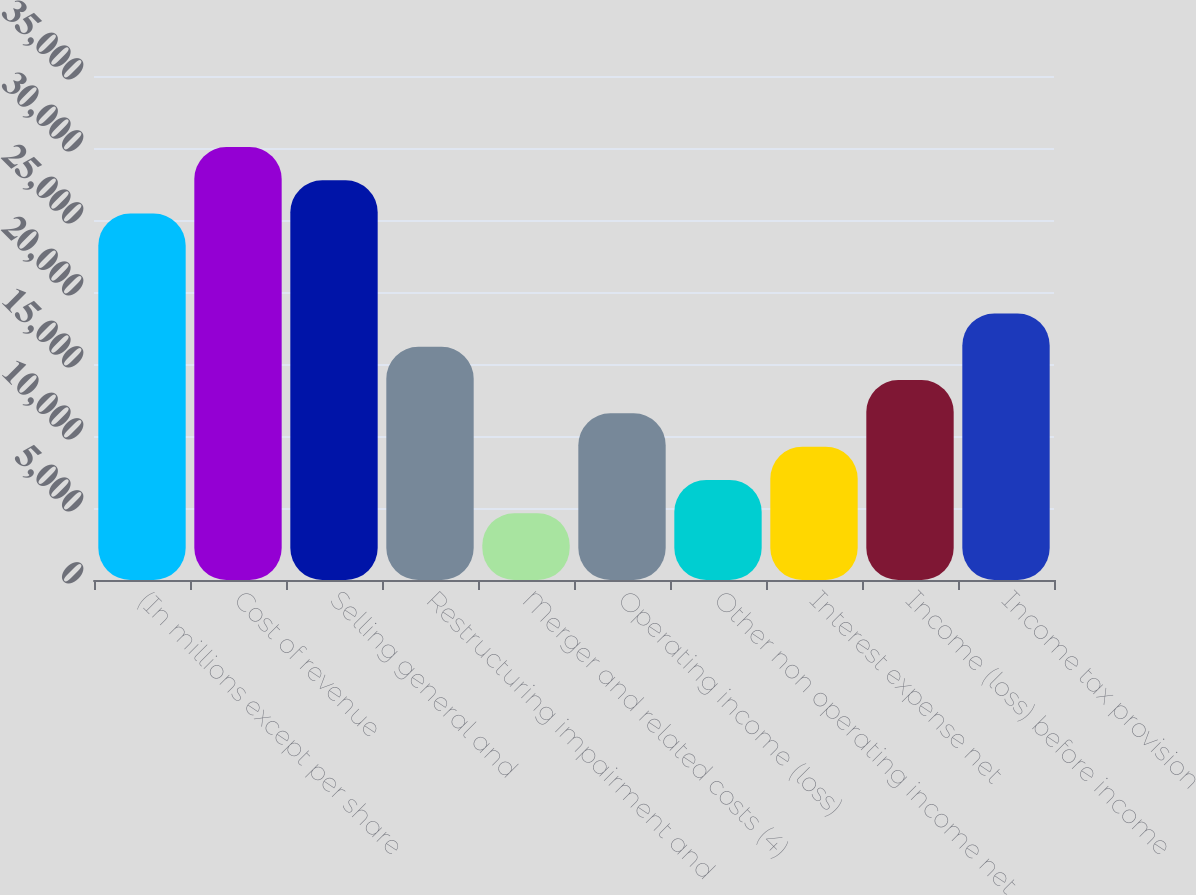Convert chart. <chart><loc_0><loc_0><loc_500><loc_500><bar_chart><fcel>(In millions except per share<fcel>Cost of revenue<fcel>Selling general and<fcel>Restructuring impairment and<fcel>Merger and related costs (4)<fcel>Operating income (loss)<fcel>Other non operating income net<fcel>Interest expense net<fcel>Income (loss) before income<fcel>Income tax provision<nl><fcel>25445<fcel>30069<fcel>27757<fcel>16197<fcel>4637<fcel>11573<fcel>6949<fcel>9261<fcel>13885<fcel>18509<nl></chart> 